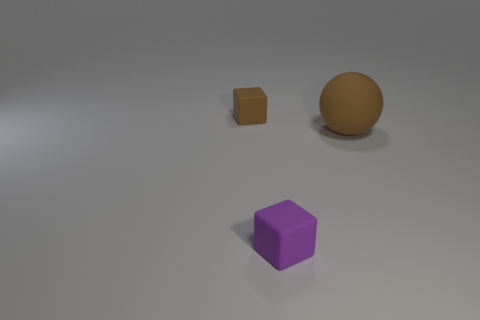Subtract 1 spheres. How many spheres are left? 0 Add 3 red matte objects. How many objects exist? 6 Subtract all purple cubes. How many cubes are left? 1 Subtract all blocks. How many objects are left? 1 Add 1 rubber things. How many rubber things are left? 4 Add 3 matte spheres. How many matte spheres exist? 4 Subtract 0 red cylinders. How many objects are left? 3 Subtract all red spheres. Subtract all brown cubes. How many spheres are left? 1 Subtract all small blocks. Subtract all tiny red blocks. How many objects are left? 1 